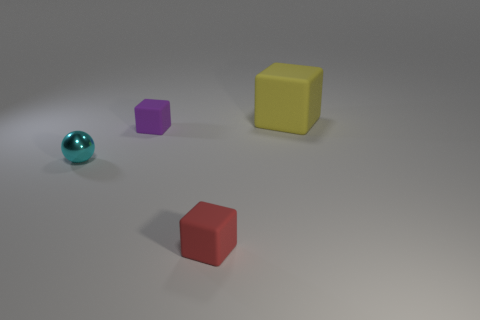Subtract all tiny rubber cubes. How many cubes are left? 1 Add 2 brown blocks. How many objects exist? 6 Subtract all purple blocks. How many blocks are left? 2 Subtract all cubes. How many objects are left? 1 Subtract all big cyan shiny blocks. Subtract all large rubber things. How many objects are left? 3 Add 4 large blocks. How many large blocks are left? 5 Add 2 yellow things. How many yellow things exist? 3 Subtract 0 purple cylinders. How many objects are left? 4 Subtract all red spheres. Subtract all purple cylinders. How many spheres are left? 1 